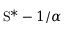<formula> <loc_0><loc_0><loc_500><loc_500>S ^ { \ast } - 1 / \alpha</formula> 